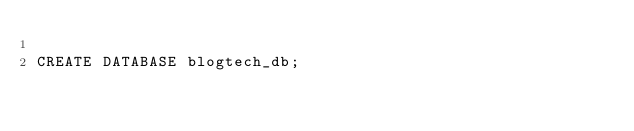Convert code to text. <code><loc_0><loc_0><loc_500><loc_500><_SQL_>
CREATE DATABASE blogtech_db;</code> 